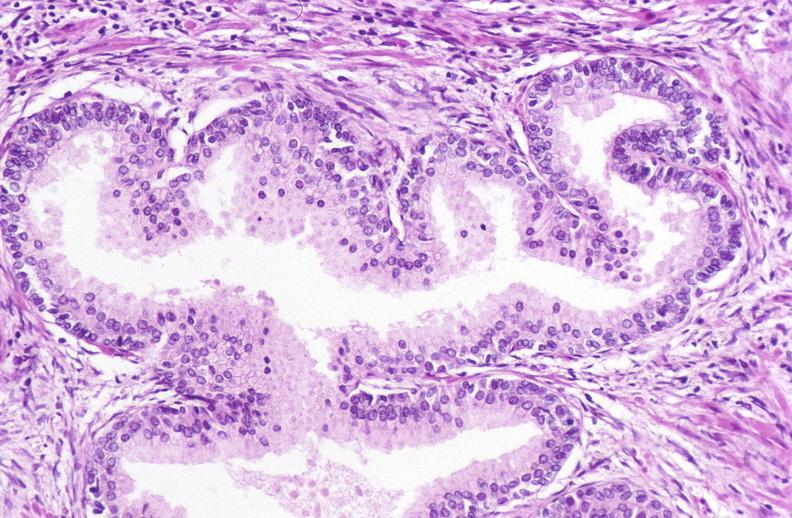what does this image show?
Answer the question using a single word or phrase. Prostate 